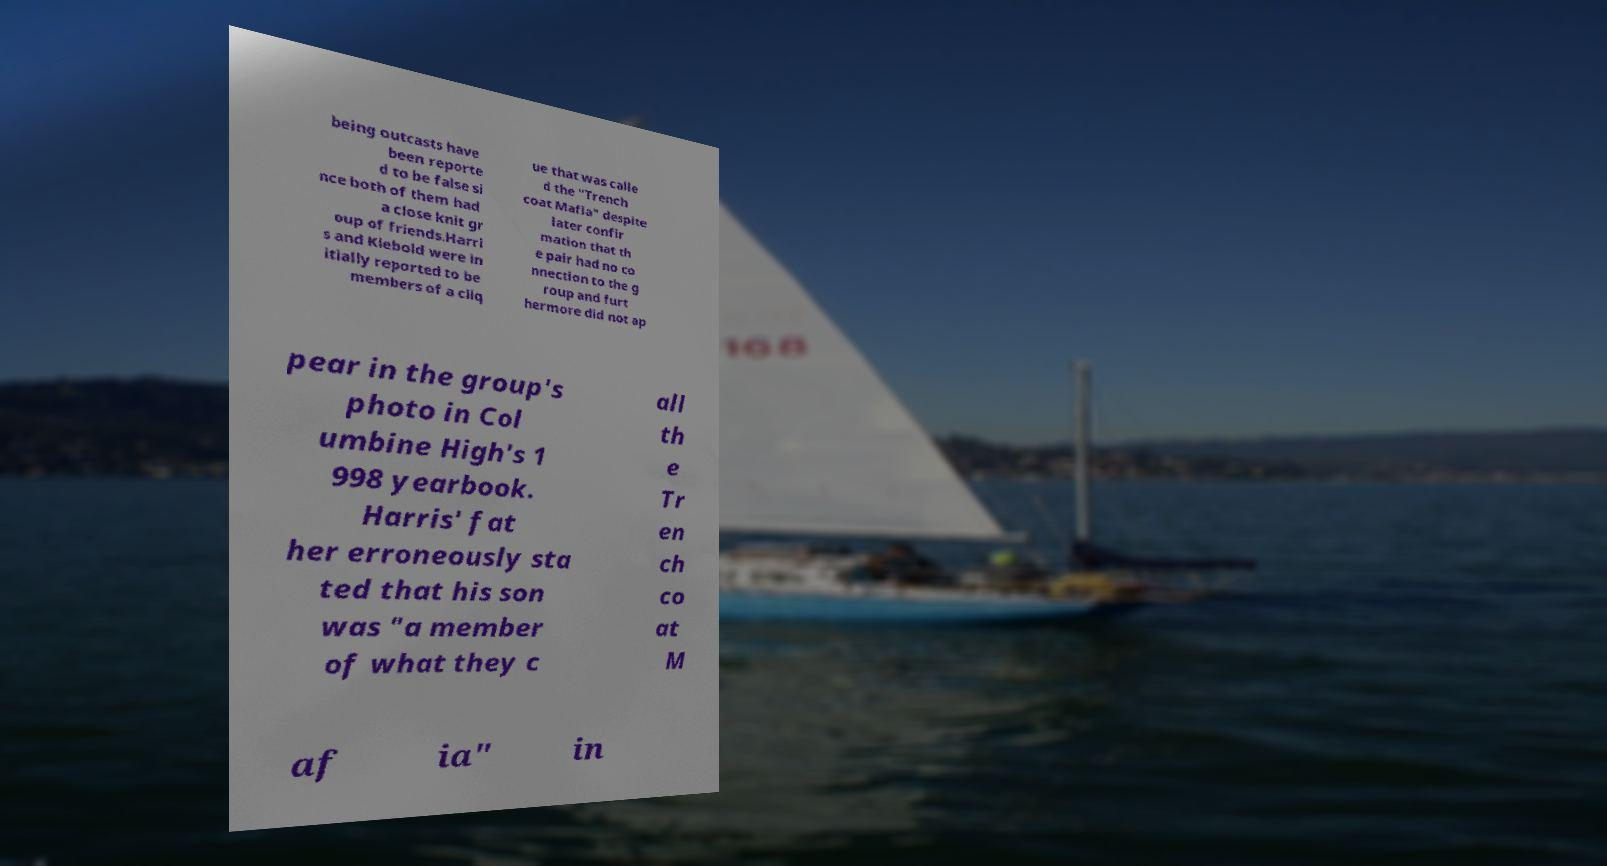Can you accurately transcribe the text from the provided image for me? being outcasts have been reporte d to be false si nce both of them had a close knit gr oup of friends.Harri s and Klebold were in itially reported to be members of a cliq ue that was calle d the "Trench coat Mafia" despite later confir mation that th e pair had no co nnection to the g roup and furt hermore did not ap pear in the group's photo in Col umbine High's 1 998 yearbook. Harris' fat her erroneously sta ted that his son was "a member of what they c all th e Tr en ch co at M af ia" in 